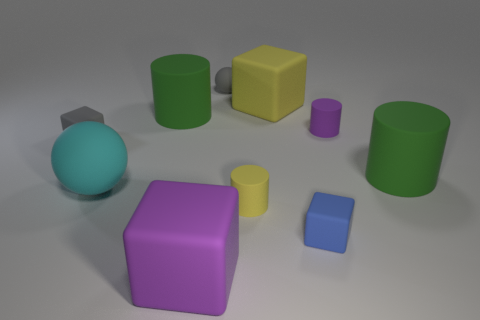What number of other objects are there of the same color as the tiny ball?
Offer a very short reply. 1. Is the shape of the blue object the same as the green rubber thing to the right of the small ball?
Provide a succinct answer. No. Is the number of cyan rubber spheres that are behind the tiny rubber sphere less than the number of yellow rubber cylinders on the left side of the large cyan matte object?
Ensure brevity in your answer.  No. What is the material of the gray object that is the same shape as the small blue thing?
Your answer should be very brief. Rubber. Is the big ball the same color as the tiny sphere?
Your answer should be compact. No. There is another yellow object that is made of the same material as the big yellow thing; what is its shape?
Provide a short and direct response. Cylinder. How many large purple rubber objects have the same shape as the large yellow rubber object?
Provide a succinct answer. 1. What shape is the large green rubber thing that is to the right of the tiny gray object that is on the right side of the small gray matte cube?
Your answer should be very brief. Cylinder. There is a green rubber object that is on the right side of the purple matte cylinder; is its size the same as the big purple rubber block?
Ensure brevity in your answer.  Yes. There is a object that is in front of the cyan matte thing and on the right side of the large yellow thing; what is its size?
Provide a short and direct response. Small. 